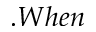<formula> <loc_0><loc_0><loc_500><loc_500>. W h e n</formula> 